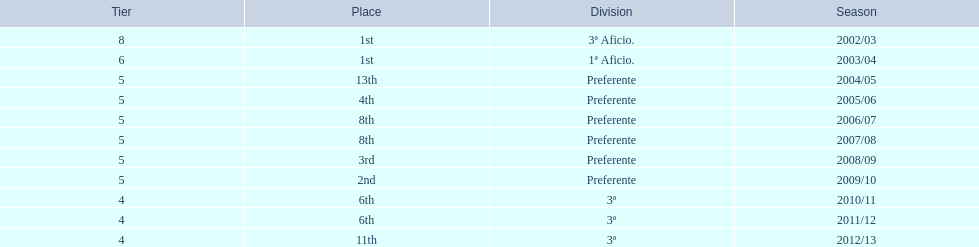How long has internacional de madrid cf been playing in the 3ª division? 3. 